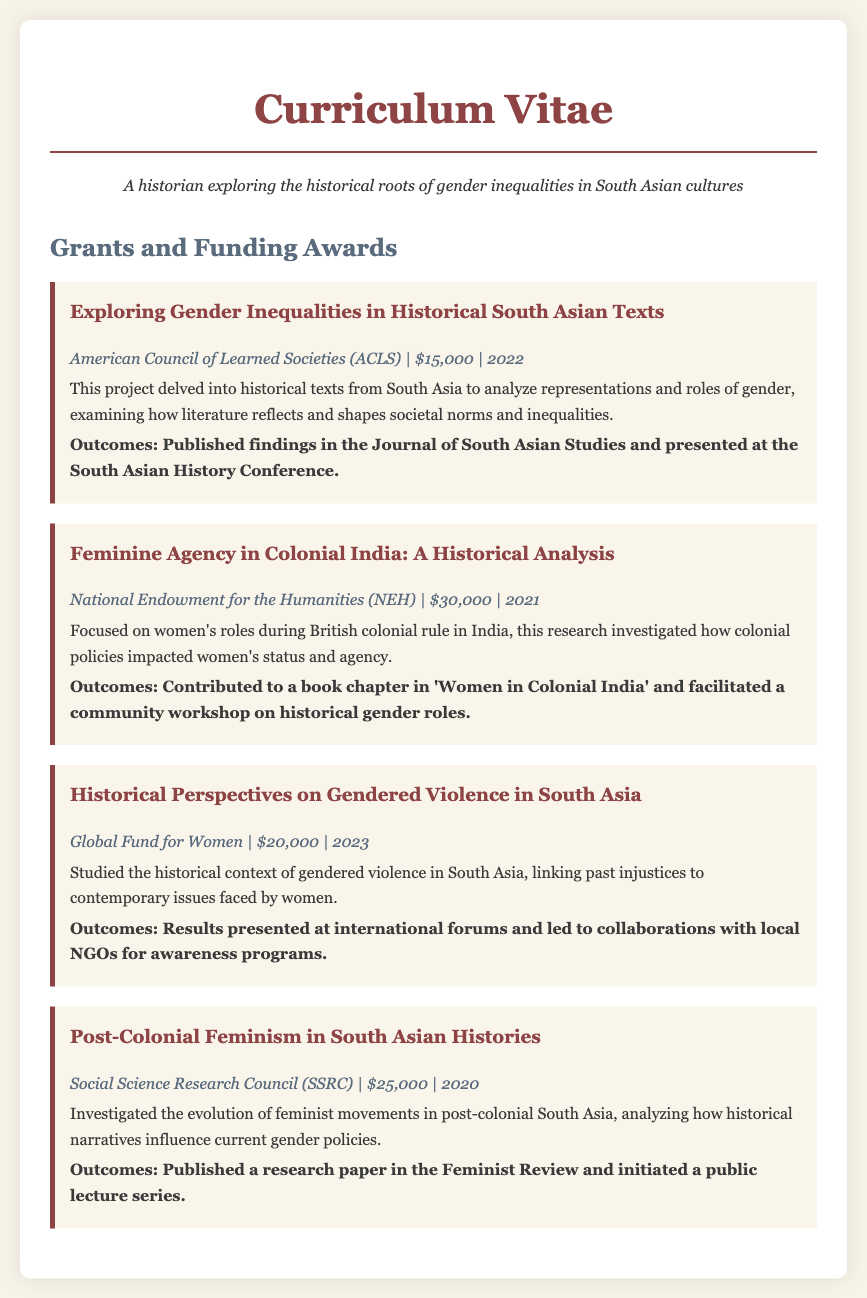What was the title of the project funded by the ACLS? The title is mentioned under the ACLS grant listing in the document.
Answer: Exploring Gender Inequalities in Historical South Asian Texts How much funding was received from the National Endowment for the Humanities? The funding amount is specified in the NEH grant section of the document.
Answer: $30,000 What year was the project on Historical Perspectives on Gendered Violence in South Asia funded? The funding year is noted within the grant details of that specific project.
Answer: 2023 Which funding body supported the research on Post-Colonial Feminism in South Asian Histories? The funding body is indicated in the SSRC grant section of the document.
Answer: Social Science Research Council (SSRC) What was one of the outcomes of the research on Feminine Agency in Colonial India? The document lists specific outcomes for each grant in their respective sections.
Answer: Contributed to a book chapter in 'Women in Colonial India' Which project has a focus on community workshops? The document describes the outcomes related to projects; this specific project mentions workshops.
Answer: Feminine Agency in Colonial India: A Historical Analysis How many projects funded over $20,000 are listed? The document includes details of the grants, allowing for a count of specific funding amounts.
Answer: 3 What is the overall theme of the grants discussed in the document? The document's title and project descriptions provide a clear idea of the main theme.
Answer: Gender inequalities in South Asian cultures 